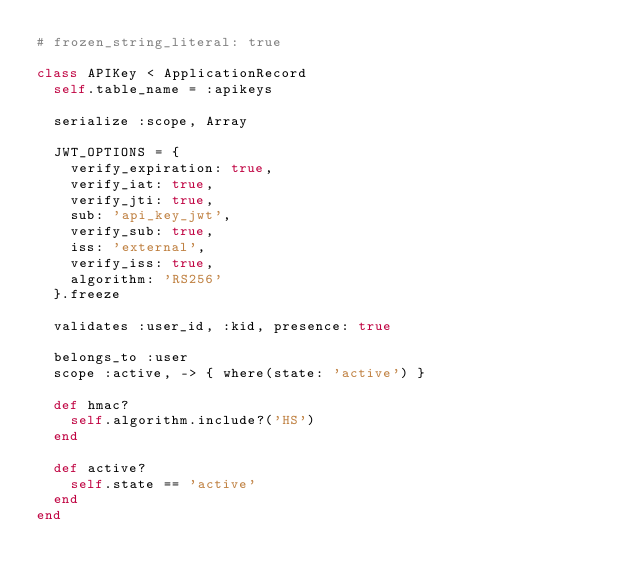<code> <loc_0><loc_0><loc_500><loc_500><_Ruby_># frozen_string_literal: true

class APIKey < ApplicationRecord
  self.table_name = :apikeys

  serialize :scope, Array

  JWT_OPTIONS = {
    verify_expiration: true,
    verify_iat: true,
    verify_jti: true,
    sub: 'api_key_jwt',
    verify_sub: true,
    iss: 'external',
    verify_iss: true,
    algorithm: 'RS256'
  }.freeze

  validates :user_id, :kid, presence: true

  belongs_to :user
  scope :active, -> { where(state: 'active') }

  def hmac?
    self.algorithm.include?('HS')
  end

  def active?
    self.state == 'active'
  end
end</code> 